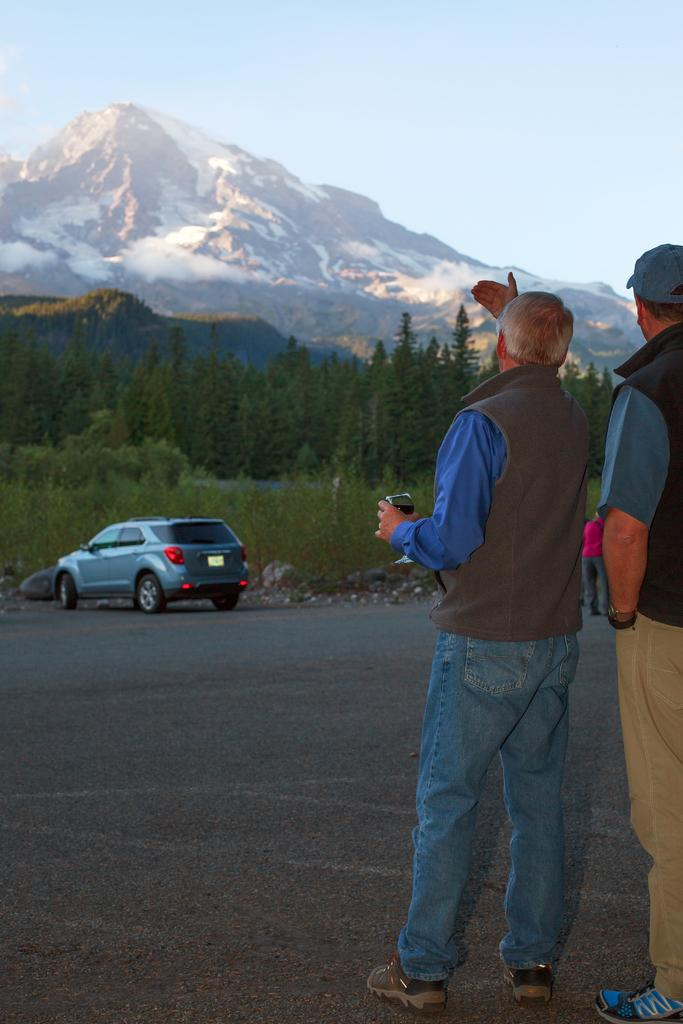How many people are in the image? There are people in the image, but the exact number is not specified. What is the man in the center of the image holding? The man in the center of the image is holding a glass. What can be seen on the road in the image? There is a car on the road in the image. What type of natural features are visible in the background of the image? There are trees and hills visible in the background of the image. What is visible in the sky in the image? The sky is visible in the background of the image. What type of cream is being used to paint the uncle's face in the image? There is no uncle or painting activity present in the image. What type of flight is the man in the center of the image preparing for? There is no mention of a flight or any travel-related activity in the image. 